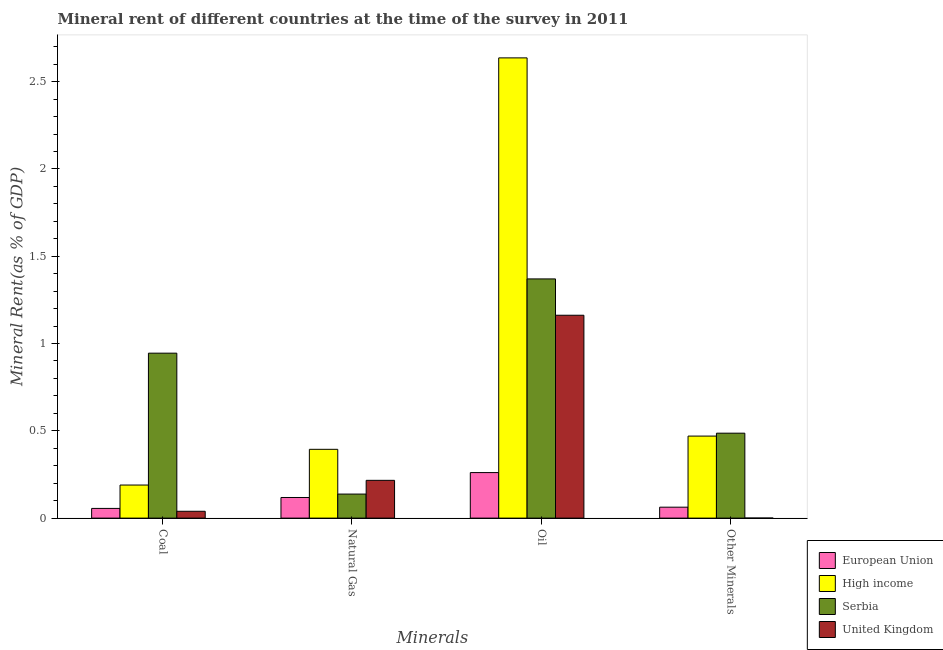How many groups of bars are there?
Ensure brevity in your answer.  4. Are the number of bars per tick equal to the number of legend labels?
Your answer should be very brief. Yes. Are the number of bars on each tick of the X-axis equal?
Keep it short and to the point. Yes. How many bars are there on the 3rd tick from the left?
Keep it short and to the point. 4. How many bars are there on the 1st tick from the right?
Provide a succinct answer. 4. What is the label of the 1st group of bars from the left?
Give a very brief answer. Coal. What is the coal rent in United Kingdom?
Your answer should be very brief. 0.04. Across all countries, what is the maximum  rent of other minerals?
Provide a short and direct response. 0.49. Across all countries, what is the minimum oil rent?
Keep it short and to the point. 0.26. In which country was the  rent of other minerals maximum?
Provide a succinct answer. Serbia. In which country was the coal rent minimum?
Your response must be concise. United Kingdom. What is the total natural gas rent in the graph?
Provide a succinct answer. 0.87. What is the difference between the natural gas rent in High income and that in United Kingdom?
Provide a short and direct response. 0.18. What is the difference between the coal rent in European Union and the  rent of other minerals in Serbia?
Your answer should be compact. -0.43. What is the average  rent of other minerals per country?
Your response must be concise. 0.25. What is the difference between the  rent of other minerals and coal rent in European Union?
Your response must be concise. 0.01. In how many countries, is the natural gas rent greater than 2.4 %?
Your answer should be compact. 0. What is the ratio of the coal rent in High income to that in United Kingdom?
Ensure brevity in your answer.  4.83. Is the natural gas rent in Serbia less than that in European Union?
Ensure brevity in your answer.  No. Is the difference between the natural gas rent in High income and United Kingdom greater than the difference between the  rent of other minerals in High income and United Kingdom?
Your answer should be compact. No. What is the difference between the highest and the second highest coal rent?
Offer a very short reply. 0.76. What is the difference between the highest and the lowest oil rent?
Ensure brevity in your answer.  2.38. Is the sum of the  rent of other minerals in United Kingdom and European Union greater than the maximum coal rent across all countries?
Provide a short and direct response. No. Is it the case that in every country, the sum of the natural gas rent and coal rent is greater than the sum of  rent of other minerals and oil rent?
Provide a short and direct response. No. What does the 2nd bar from the right in Natural Gas represents?
Keep it short and to the point. Serbia. Is it the case that in every country, the sum of the coal rent and natural gas rent is greater than the oil rent?
Your answer should be compact. No. How many countries are there in the graph?
Ensure brevity in your answer.  4. What is the difference between two consecutive major ticks on the Y-axis?
Offer a very short reply. 0.5. Are the values on the major ticks of Y-axis written in scientific E-notation?
Give a very brief answer. No. Does the graph contain grids?
Provide a short and direct response. No. How many legend labels are there?
Make the answer very short. 4. What is the title of the graph?
Make the answer very short. Mineral rent of different countries at the time of the survey in 2011. Does "South Asia" appear as one of the legend labels in the graph?
Provide a short and direct response. No. What is the label or title of the X-axis?
Give a very brief answer. Minerals. What is the label or title of the Y-axis?
Your answer should be compact. Mineral Rent(as % of GDP). What is the Mineral Rent(as % of GDP) in European Union in Coal?
Your response must be concise. 0.06. What is the Mineral Rent(as % of GDP) in High income in Coal?
Make the answer very short. 0.19. What is the Mineral Rent(as % of GDP) in Serbia in Coal?
Your answer should be very brief. 0.94. What is the Mineral Rent(as % of GDP) of United Kingdom in Coal?
Offer a very short reply. 0.04. What is the Mineral Rent(as % of GDP) in European Union in Natural Gas?
Keep it short and to the point. 0.12. What is the Mineral Rent(as % of GDP) in High income in Natural Gas?
Ensure brevity in your answer.  0.39. What is the Mineral Rent(as % of GDP) of Serbia in Natural Gas?
Ensure brevity in your answer.  0.14. What is the Mineral Rent(as % of GDP) of United Kingdom in Natural Gas?
Provide a short and direct response. 0.22. What is the Mineral Rent(as % of GDP) in European Union in Oil?
Ensure brevity in your answer.  0.26. What is the Mineral Rent(as % of GDP) of High income in Oil?
Make the answer very short. 2.64. What is the Mineral Rent(as % of GDP) of Serbia in Oil?
Ensure brevity in your answer.  1.37. What is the Mineral Rent(as % of GDP) in United Kingdom in Oil?
Your response must be concise. 1.16. What is the Mineral Rent(as % of GDP) of European Union in Other Minerals?
Provide a succinct answer. 0.06. What is the Mineral Rent(as % of GDP) of High income in Other Minerals?
Keep it short and to the point. 0.47. What is the Mineral Rent(as % of GDP) of Serbia in Other Minerals?
Offer a terse response. 0.49. What is the Mineral Rent(as % of GDP) of United Kingdom in Other Minerals?
Offer a terse response. 0. Across all Minerals, what is the maximum Mineral Rent(as % of GDP) of European Union?
Offer a very short reply. 0.26. Across all Minerals, what is the maximum Mineral Rent(as % of GDP) of High income?
Give a very brief answer. 2.64. Across all Minerals, what is the maximum Mineral Rent(as % of GDP) in Serbia?
Give a very brief answer. 1.37. Across all Minerals, what is the maximum Mineral Rent(as % of GDP) of United Kingdom?
Provide a short and direct response. 1.16. Across all Minerals, what is the minimum Mineral Rent(as % of GDP) of European Union?
Offer a terse response. 0.06. Across all Minerals, what is the minimum Mineral Rent(as % of GDP) in High income?
Give a very brief answer. 0.19. Across all Minerals, what is the minimum Mineral Rent(as % of GDP) in Serbia?
Give a very brief answer. 0.14. Across all Minerals, what is the minimum Mineral Rent(as % of GDP) of United Kingdom?
Offer a terse response. 0. What is the total Mineral Rent(as % of GDP) in European Union in the graph?
Your answer should be compact. 0.5. What is the total Mineral Rent(as % of GDP) of High income in the graph?
Ensure brevity in your answer.  3.69. What is the total Mineral Rent(as % of GDP) of Serbia in the graph?
Keep it short and to the point. 2.94. What is the total Mineral Rent(as % of GDP) of United Kingdom in the graph?
Make the answer very short. 1.42. What is the difference between the Mineral Rent(as % of GDP) of European Union in Coal and that in Natural Gas?
Your answer should be very brief. -0.06. What is the difference between the Mineral Rent(as % of GDP) of High income in Coal and that in Natural Gas?
Make the answer very short. -0.2. What is the difference between the Mineral Rent(as % of GDP) of Serbia in Coal and that in Natural Gas?
Your response must be concise. 0.81. What is the difference between the Mineral Rent(as % of GDP) in United Kingdom in Coal and that in Natural Gas?
Your answer should be compact. -0.18. What is the difference between the Mineral Rent(as % of GDP) in European Union in Coal and that in Oil?
Your answer should be very brief. -0.21. What is the difference between the Mineral Rent(as % of GDP) of High income in Coal and that in Oil?
Offer a terse response. -2.45. What is the difference between the Mineral Rent(as % of GDP) of Serbia in Coal and that in Oil?
Provide a succinct answer. -0.43. What is the difference between the Mineral Rent(as % of GDP) of United Kingdom in Coal and that in Oil?
Your response must be concise. -1.12. What is the difference between the Mineral Rent(as % of GDP) of European Union in Coal and that in Other Minerals?
Make the answer very short. -0.01. What is the difference between the Mineral Rent(as % of GDP) in High income in Coal and that in Other Minerals?
Your answer should be compact. -0.28. What is the difference between the Mineral Rent(as % of GDP) of Serbia in Coal and that in Other Minerals?
Provide a succinct answer. 0.46. What is the difference between the Mineral Rent(as % of GDP) of United Kingdom in Coal and that in Other Minerals?
Your answer should be very brief. 0.04. What is the difference between the Mineral Rent(as % of GDP) in European Union in Natural Gas and that in Oil?
Keep it short and to the point. -0.14. What is the difference between the Mineral Rent(as % of GDP) in High income in Natural Gas and that in Oil?
Give a very brief answer. -2.24. What is the difference between the Mineral Rent(as % of GDP) of Serbia in Natural Gas and that in Oil?
Keep it short and to the point. -1.23. What is the difference between the Mineral Rent(as % of GDP) in United Kingdom in Natural Gas and that in Oil?
Give a very brief answer. -0.95. What is the difference between the Mineral Rent(as % of GDP) in European Union in Natural Gas and that in Other Minerals?
Your answer should be compact. 0.06. What is the difference between the Mineral Rent(as % of GDP) of High income in Natural Gas and that in Other Minerals?
Keep it short and to the point. -0.08. What is the difference between the Mineral Rent(as % of GDP) in Serbia in Natural Gas and that in Other Minerals?
Make the answer very short. -0.35. What is the difference between the Mineral Rent(as % of GDP) of United Kingdom in Natural Gas and that in Other Minerals?
Make the answer very short. 0.22. What is the difference between the Mineral Rent(as % of GDP) of European Union in Oil and that in Other Minerals?
Offer a terse response. 0.2. What is the difference between the Mineral Rent(as % of GDP) of High income in Oil and that in Other Minerals?
Offer a very short reply. 2.17. What is the difference between the Mineral Rent(as % of GDP) in Serbia in Oil and that in Other Minerals?
Provide a succinct answer. 0.88. What is the difference between the Mineral Rent(as % of GDP) in United Kingdom in Oil and that in Other Minerals?
Ensure brevity in your answer.  1.16. What is the difference between the Mineral Rent(as % of GDP) of European Union in Coal and the Mineral Rent(as % of GDP) of High income in Natural Gas?
Make the answer very short. -0.34. What is the difference between the Mineral Rent(as % of GDP) of European Union in Coal and the Mineral Rent(as % of GDP) of Serbia in Natural Gas?
Provide a short and direct response. -0.08. What is the difference between the Mineral Rent(as % of GDP) in European Union in Coal and the Mineral Rent(as % of GDP) in United Kingdom in Natural Gas?
Ensure brevity in your answer.  -0.16. What is the difference between the Mineral Rent(as % of GDP) in High income in Coal and the Mineral Rent(as % of GDP) in Serbia in Natural Gas?
Your answer should be compact. 0.05. What is the difference between the Mineral Rent(as % of GDP) of High income in Coal and the Mineral Rent(as % of GDP) of United Kingdom in Natural Gas?
Provide a succinct answer. -0.03. What is the difference between the Mineral Rent(as % of GDP) in Serbia in Coal and the Mineral Rent(as % of GDP) in United Kingdom in Natural Gas?
Keep it short and to the point. 0.73. What is the difference between the Mineral Rent(as % of GDP) of European Union in Coal and the Mineral Rent(as % of GDP) of High income in Oil?
Offer a terse response. -2.58. What is the difference between the Mineral Rent(as % of GDP) in European Union in Coal and the Mineral Rent(as % of GDP) in Serbia in Oil?
Your response must be concise. -1.31. What is the difference between the Mineral Rent(as % of GDP) of European Union in Coal and the Mineral Rent(as % of GDP) of United Kingdom in Oil?
Offer a terse response. -1.11. What is the difference between the Mineral Rent(as % of GDP) in High income in Coal and the Mineral Rent(as % of GDP) in Serbia in Oil?
Give a very brief answer. -1.18. What is the difference between the Mineral Rent(as % of GDP) in High income in Coal and the Mineral Rent(as % of GDP) in United Kingdom in Oil?
Keep it short and to the point. -0.97. What is the difference between the Mineral Rent(as % of GDP) in Serbia in Coal and the Mineral Rent(as % of GDP) in United Kingdom in Oil?
Your answer should be compact. -0.22. What is the difference between the Mineral Rent(as % of GDP) of European Union in Coal and the Mineral Rent(as % of GDP) of High income in Other Minerals?
Make the answer very short. -0.41. What is the difference between the Mineral Rent(as % of GDP) in European Union in Coal and the Mineral Rent(as % of GDP) in Serbia in Other Minerals?
Provide a succinct answer. -0.43. What is the difference between the Mineral Rent(as % of GDP) in European Union in Coal and the Mineral Rent(as % of GDP) in United Kingdom in Other Minerals?
Your answer should be compact. 0.06. What is the difference between the Mineral Rent(as % of GDP) in High income in Coal and the Mineral Rent(as % of GDP) in Serbia in Other Minerals?
Provide a succinct answer. -0.3. What is the difference between the Mineral Rent(as % of GDP) of High income in Coal and the Mineral Rent(as % of GDP) of United Kingdom in Other Minerals?
Your response must be concise. 0.19. What is the difference between the Mineral Rent(as % of GDP) in Serbia in Coal and the Mineral Rent(as % of GDP) in United Kingdom in Other Minerals?
Keep it short and to the point. 0.94. What is the difference between the Mineral Rent(as % of GDP) of European Union in Natural Gas and the Mineral Rent(as % of GDP) of High income in Oil?
Your response must be concise. -2.52. What is the difference between the Mineral Rent(as % of GDP) of European Union in Natural Gas and the Mineral Rent(as % of GDP) of Serbia in Oil?
Give a very brief answer. -1.25. What is the difference between the Mineral Rent(as % of GDP) in European Union in Natural Gas and the Mineral Rent(as % of GDP) in United Kingdom in Oil?
Your response must be concise. -1.04. What is the difference between the Mineral Rent(as % of GDP) of High income in Natural Gas and the Mineral Rent(as % of GDP) of Serbia in Oil?
Ensure brevity in your answer.  -0.98. What is the difference between the Mineral Rent(as % of GDP) of High income in Natural Gas and the Mineral Rent(as % of GDP) of United Kingdom in Oil?
Ensure brevity in your answer.  -0.77. What is the difference between the Mineral Rent(as % of GDP) of Serbia in Natural Gas and the Mineral Rent(as % of GDP) of United Kingdom in Oil?
Your answer should be compact. -1.02. What is the difference between the Mineral Rent(as % of GDP) in European Union in Natural Gas and the Mineral Rent(as % of GDP) in High income in Other Minerals?
Your response must be concise. -0.35. What is the difference between the Mineral Rent(as % of GDP) of European Union in Natural Gas and the Mineral Rent(as % of GDP) of Serbia in Other Minerals?
Offer a very short reply. -0.37. What is the difference between the Mineral Rent(as % of GDP) in European Union in Natural Gas and the Mineral Rent(as % of GDP) in United Kingdom in Other Minerals?
Make the answer very short. 0.12. What is the difference between the Mineral Rent(as % of GDP) in High income in Natural Gas and the Mineral Rent(as % of GDP) in Serbia in Other Minerals?
Offer a terse response. -0.09. What is the difference between the Mineral Rent(as % of GDP) of High income in Natural Gas and the Mineral Rent(as % of GDP) of United Kingdom in Other Minerals?
Offer a terse response. 0.39. What is the difference between the Mineral Rent(as % of GDP) of Serbia in Natural Gas and the Mineral Rent(as % of GDP) of United Kingdom in Other Minerals?
Keep it short and to the point. 0.14. What is the difference between the Mineral Rent(as % of GDP) in European Union in Oil and the Mineral Rent(as % of GDP) in High income in Other Minerals?
Offer a very short reply. -0.21. What is the difference between the Mineral Rent(as % of GDP) in European Union in Oil and the Mineral Rent(as % of GDP) in Serbia in Other Minerals?
Your answer should be compact. -0.23. What is the difference between the Mineral Rent(as % of GDP) of European Union in Oil and the Mineral Rent(as % of GDP) of United Kingdom in Other Minerals?
Your response must be concise. 0.26. What is the difference between the Mineral Rent(as % of GDP) in High income in Oil and the Mineral Rent(as % of GDP) in Serbia in Other Minerals?
Your answer should be compact. 2.15. What is the difference between the Mineral Rent(as % of GDP) in High income in Oil and the Mineral Rent(as % of GDP) in United Kingdom in Other Minerals?
Your answer should be very brief. 2.64. What is the difference between the Mineral Rent(as % of GDP) of Serbia in Oil and the Mineral Rent(as % of GDP) of United Kingdom in Other Minerals?
Make the answer very short. 1.37. What is the average Mineral Rent(as % of GDP) of European Union per Minerals?
Offer a terse response. 0.12. What is the average Mineral Rent(as % of GDP) in High income per Minerals?
Make the answer very short. 0.92. What is the average Mineral Rent(as % of GDP) in Serbia per Minerals?
Ensure brevity in your answer.  0.73. What is the average Mineral Rent(as % of GDP) of United Kingdom per Minerals?
Your answer should be compact. 0.35. What is the difference between the Mineral Rent(as % of GDP) of European Union and Mineral Rent(as % of GDP) of High income in Coal?
Keep it short and to the point. -0.13. What is the difference between the Mineral Rent(as % of GDP) of European Union and Mineral Rent(as % of GDP) of Serbia in Coal?
Your response must be concise. -0.89. What is the difference between the Mineral Rent(as % of GDP) of European Union and Mineral Rent(as % of GDP) of United Kingdom in Coal?
Your response must be concise. 0.02. What is the difference between the Mineral Rent(as % of GDP) of High income and Mineral Rent(as % of GDP) of Serbia in Coal?
Offer a terse response. -0.76. What is the difference between the Mineral Rent(as % of GDP) of High income and Mineral Rent(as % of GDP) of United Kingdom in Coal?
Offer a very short reply. 0.15. What is the difference between the Mineral Rent(as % of GDP) in Serbia and Mineral Rent(as % of GDP) in United Kingdom in Coal?
Offer a terse response. 0.91. What is the difference between the Mineral Rent(as % of GDP) of European Union and Mineral Rent(as % of GDP) of High income in Natural Gas?
Give a very brief answer. -0.28. What is the difference between the Mineral Rent(as % of GDP) of European Union and Mineral Rent(as % of GDP) of Serbia in Natural Gas?
Make the answer very short. -0.02. What is the difference between the Mineral Rent(as % of GDP) in European Union and Mineral Rent(as % of GDP) in United Kingdom in Natural Gas?
Ensure brevity in your answer.  -0.1. What is the difference between the Mineral Rent(as % of GDP) in High income and Mineral Rent(as % of GDP) in Serbia in Natural Gas?
Give a very brief answer. 0.26. What is the difference between the Mineral Rent(as % of GDP) in High income and Mineral Rent(as % of GDP) in United Kingdom in Natural Gas?
Give a very brief answer. 0.18. What is the difference between the Mineral Rent(as % of GDP) of Serbia and Mineral Rent(as % of GDP) of United Kingdom in Natural Gas?
Offer a terse response. -0.08. What is the difference between the Mineral Rent(as % of GDP) of European Union and Mineral Rent(as % of GDP) of High income in Oil?
Your response must be concise. -2.38. What is the difference between the Mineral Rent(as % of GDP) of European Union and Mineral Rent(as % of GDP) of Serbia in Oil?
Your answer should be very brief. -1.11. What is the difference between the Mineral Rent(as % of GDP) of European Union and Mineral Rent(as % of GDP) of United Kingdom in Oil?
Make the answer very short. -0.9. What is the difference between the Mineral Rent(as % of GDP) in High income and Mineral Rent(as % of GDP) in Serbia in Oil?
Your response must be concise. 1.27. What is the difference between the Mineral Rent(as % of GDP) in High income and Mineral Rent(as % of GDP) in United Kingdom in Oil?
Give a very brief answer. 1.47. What is the difference between the Mineral Rent(as % of GDP) of Serbia and Mineral Rent(as % of GDP) of United Kingdom in Oil?
Provide a short and direct response. 0.21. What is the difference between the Mineral Rent(as % of GDP) of European Union and Mineral Rent(as % of GDP) of High income in Other Minerals?
Ensure brevity in your answer.  -0.41. What is the difference between the Mineral Rent(as % of GDP) of European Union and Mineral Rent(as % of GDP) of Serbia in Other Minerals?
Ensure brevity in your answer.  -0.42. What is the difference between the Mineral Rent(as % of GDP) in European Union and Mineral Rent(as % of GDP) in United Kingdom in Other Minerals?
Keep it short and to the point. 0.06. What is the difference between the Mineral Rent(as % of GDP) of High income and Mineral Rent(as % of GDP) of Serbia in Other Minerals?
Your answer should be compact. -0.02. What is the difference between the Mineral Rent(as % of GDP) in High income and Mineral Rent(as % of GDP) in United Kingdom in Other Minerals?
Provide a succinct answer. 0.47. What is the difference between the Mineral Rent(as % of GDP) in Serbia and Mineral Rent(as % of GDP) in United Kingdom in Other Minerals?
Provide a succinct answer. 0.49. What is the ratio of the Mineral Rent(as % of GDP) in European Union in Coal to that in Natural Gas?
Provide a short and direct response. 0.47. What is the ratio of the Mineral Rent(as % of GDP) of High income in Coal to that in Natural Gas?
Ensure brevity in your answer.  0.48. What is the ratio of the Mineral Rent(as % of GDP) of Serbia in Coal to that in Natural Gas?
Ensure brevity in your answer.  6.86. What is the ratio of the Mineral Rent(as % of GDP) in United Kingdom in Coal to that in Natural Gas?
Provide a succinct answer. 0.18. What is the ratio of the Mineral Rent(as % of GDP) in European Union in Coal to that in Oil?
Keep it short and to the point. 0.21. What is the ratio of the Mineral Rent(as % of GDP) in High income in Coal to that in Oil?
Keep it short and to the point. 0.07. What is the ratio of the Mineral Rent(as % of GDP) in Serbia in Coal to that in Oil?
Your response must be concise. 0.69. What is the ratio of the Mineral Rent(as % of GDP) in United Kingdom in Coal to that in Oil?
Your answer should be very brief. 0.03. What is the ratio of the Mineral Rent(as % of GDP) of European Union in Coal to that in Other Minerals?
Your answer should be compact. 0.89. What is the ratio of the Mineral Rent(as % of GDP) of High income in Coal to that in Other Minerals?
Keep it short and to the point. 0.4. What is the ratio of the Mineral Rent(as % of GDP) in Serbia in Coal to that in Other Minerals?
Your answer should be compact. 1.94. What is the ratio of the Mineral Rent(as % of GDP) in United Kingdom in Coal to that in Other Minerals?
Ensure brevity in your answer.  118.88. What is the ratio of the Mineral Rent(as % of GDP) in European Union in Natural Gas to that in Oil?
Provide a short and direct response. 0.45. What is the ratio of the Mineral Rent(as % of GDP) in High income in Natural Gas to that in Oil?
Provide a short and direct response. 0.15. What is the ratio of the Mineral Rent(as % of GDP) of Serbia in Natural Gas to that in Oil?
Your answer should be compact. 0.1. What is the ratio of the Mineral Rent(as % of GDP) of United Kingdom in Natural Gas to that in Oil?
Make the answer very short. 0.19. What is the ratio of the Mineral Rent(as % of GDP) in European Union in Natural Gas to that in Other Minerals?
Offer a very short reply. 1.88. What is the ratio of the Mineral Rent(as % of GDP) of High income in Natural Gas to that in Other Minerals?
Provide a short and direct response. 0.84. What is the ratio of the Mineral Rent(as % of GDP) of Serbia in Natural Gas to that in Other Minerals?
Your answer should be very brief. 0.28. What is the ratio of the Mineral Rent(as % of GDP) of United Kingdom in Natural Gas to that in Other Minerals?
Your answer should be very brief. 655.76. What is the ratio of the Mineral Rent(as % of GDP) in European Union in Oil to that in Other Minerals?
Give a very brief answer. 4.16. What is the ratio of the Mineral Rent(as % of GDP) in High income in Oil to that in Other Minerals?
Give a very brief answer. 5.61. What is the ratio of the Mineral Rent(as % of GDP) of Serbia in Oil to that in Other Minerals?
Provide a succinct answer. 2.82. What is the ratio of the Mineral Rent(as % of GDP) of United Kingdom in Oil to that in Other Minerals?
Your response must be concise. 3521.03. What is the difference between the highest and the second highest Mineral Rent(as % of GDP) in European Union?
Keep it short and to the point. 0.14. What is the difference between the highest and the second highest Mineral Rent(as % of GDP) of High income?
Offer a terse response. 2.17. What is the difference between the highest and the second highest Mineral Rent(as % of GDP) in Serbia?
Ensure brevity in your answer.  0.43. What is the difference between the highest and the second highest Mineral Rent(as % of GDP) in United Kingdom?
Offer a terse response. 0.95. What is the difference between the highest and the lowest Mineral Rent(as % of GDP) in European Union?
Give a very brief answer. 0.21. What is the difference between the highest and the lowest Mineral Rent(as % of GDP) in High income?
Your response must be concise. 2.45. What is the difference between the highest and the lowest Mineral Rent(as % of GDP) of Serbia?
Offer a very short reply. 1.23. What is the difference between the highest and the lowest Mineral Rent(as % of GDP) of United Kingdom?
Provide a short and direct response. 1.16. 